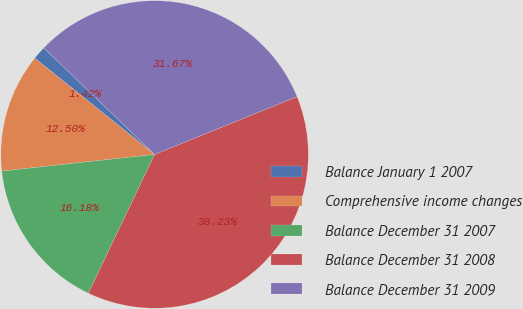<chart> <loc_0><loc_0><loc_500><loc_500><pie_chart><fcel>Balance January 1 2007<fcel>Comprehensive income changes<fcel>Balance December 31 2007<fcel>Balance December 31 2008<fcel>Balance December 31 2009<nl><fcel>1.42%<fcel>12.5%<fcel>16.18%<fcel>38.23%<fcel>31.67%<nl></chart> 